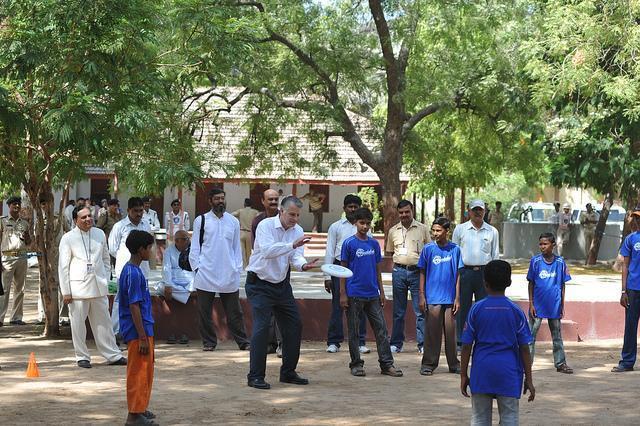How many boys have on blue shirts?
Give a very brief answer. 6. How many people can you see?
Give a very brief answer. 11. 